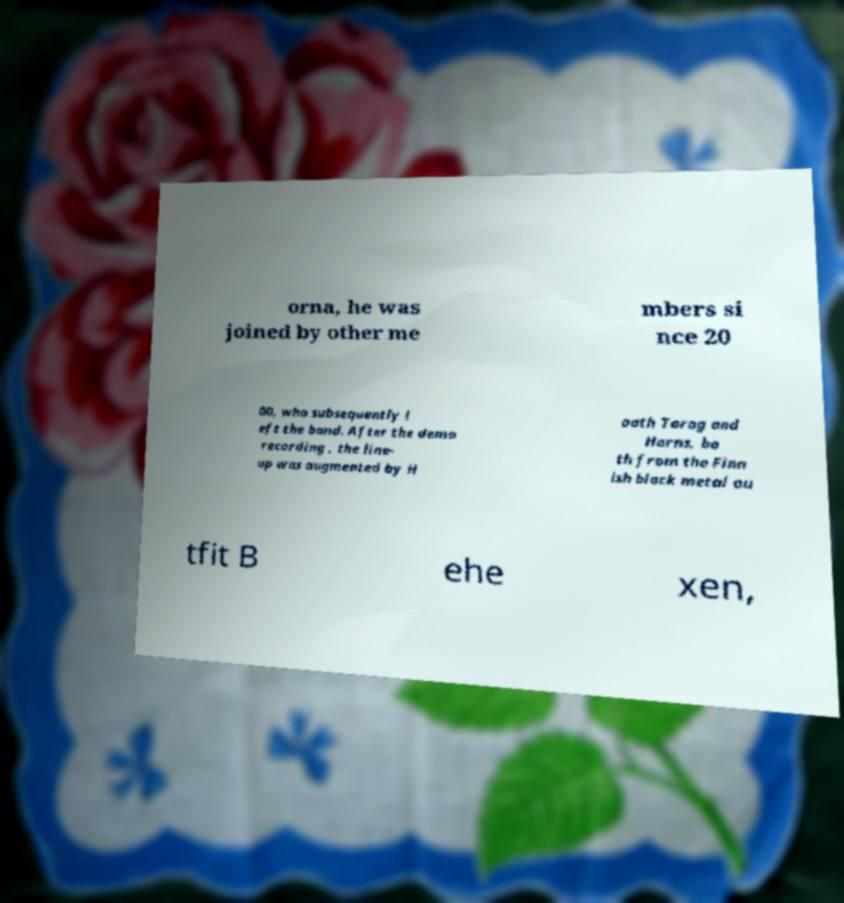There's text embedded in this image that I need extracted. Can you transcribe it verbatim? orna, he was joined by other me mbers si nce 20 00, who subsequently l eft the band. After the demo recording , the line- up was augmented by H oath Torog and Horns, bo th from the Finn ish black metal ou tfit B ehe xen, 